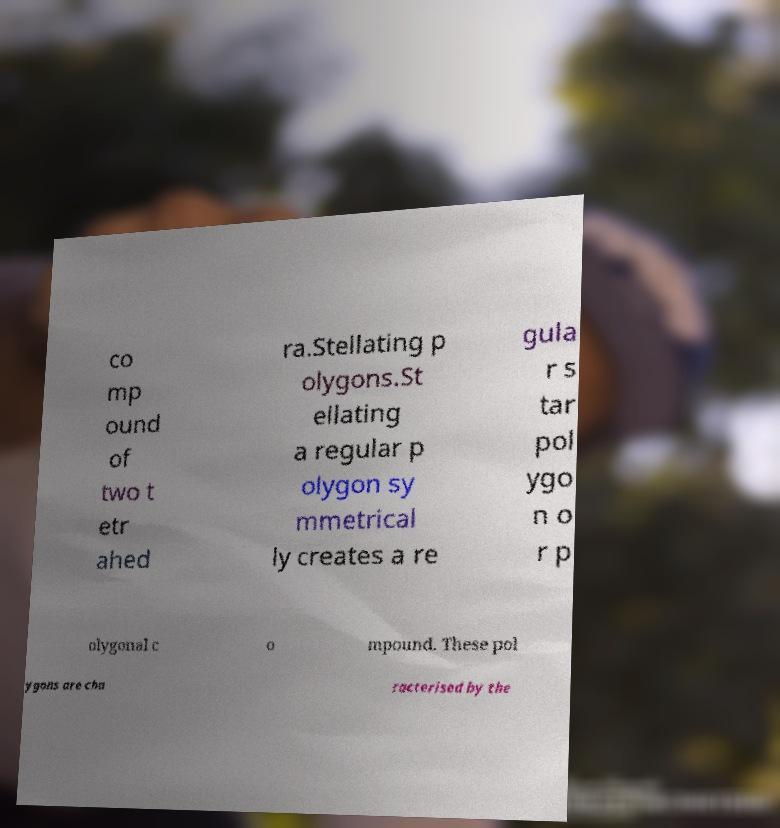Can you read and provide the text displayed in the image?This photo seems to have some interesting text. Can you extract and type it out for me? co mp ound of two t etr ahed ra.Stellating p olygons.St ellating a regular p olygon sy mmetrical ly creates a re gula r s tar pol ygo n o r p olygonal c o mpound. These pol ygons are cha racterised by the 